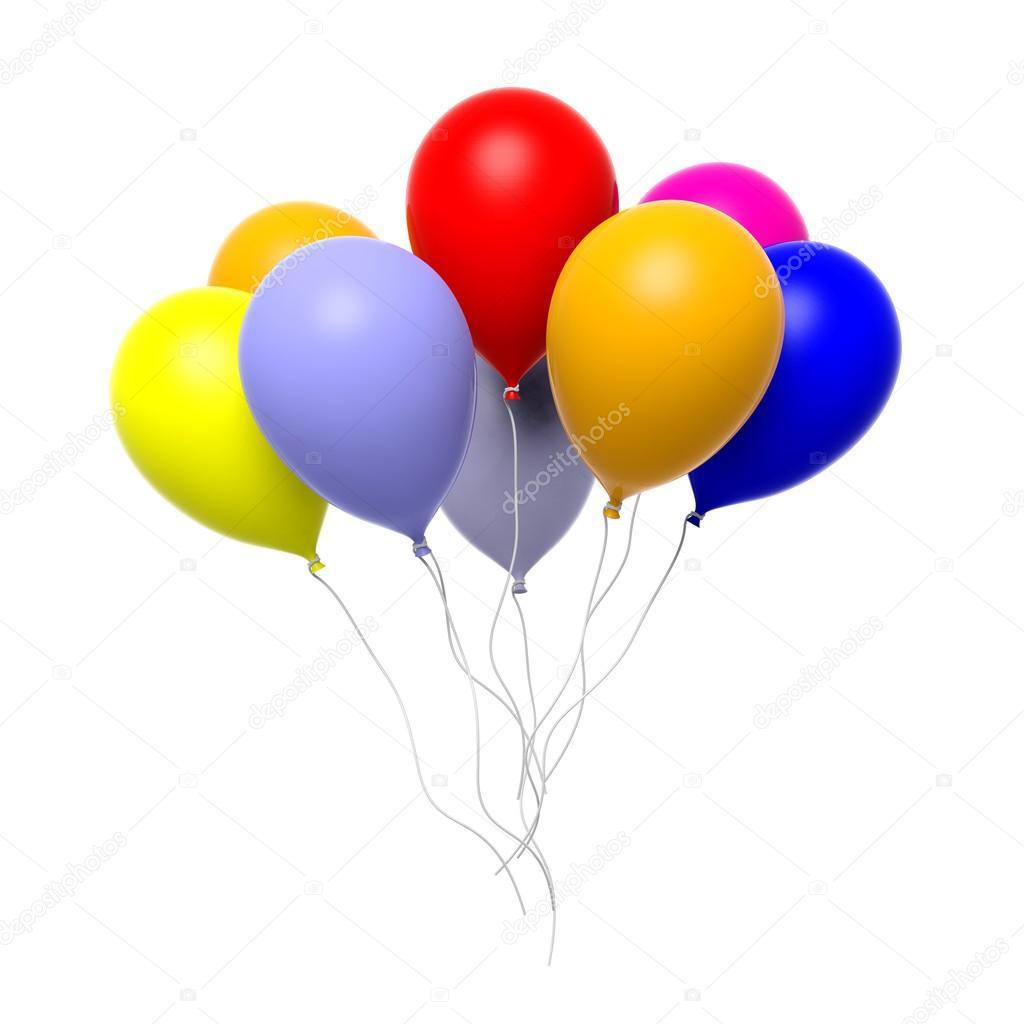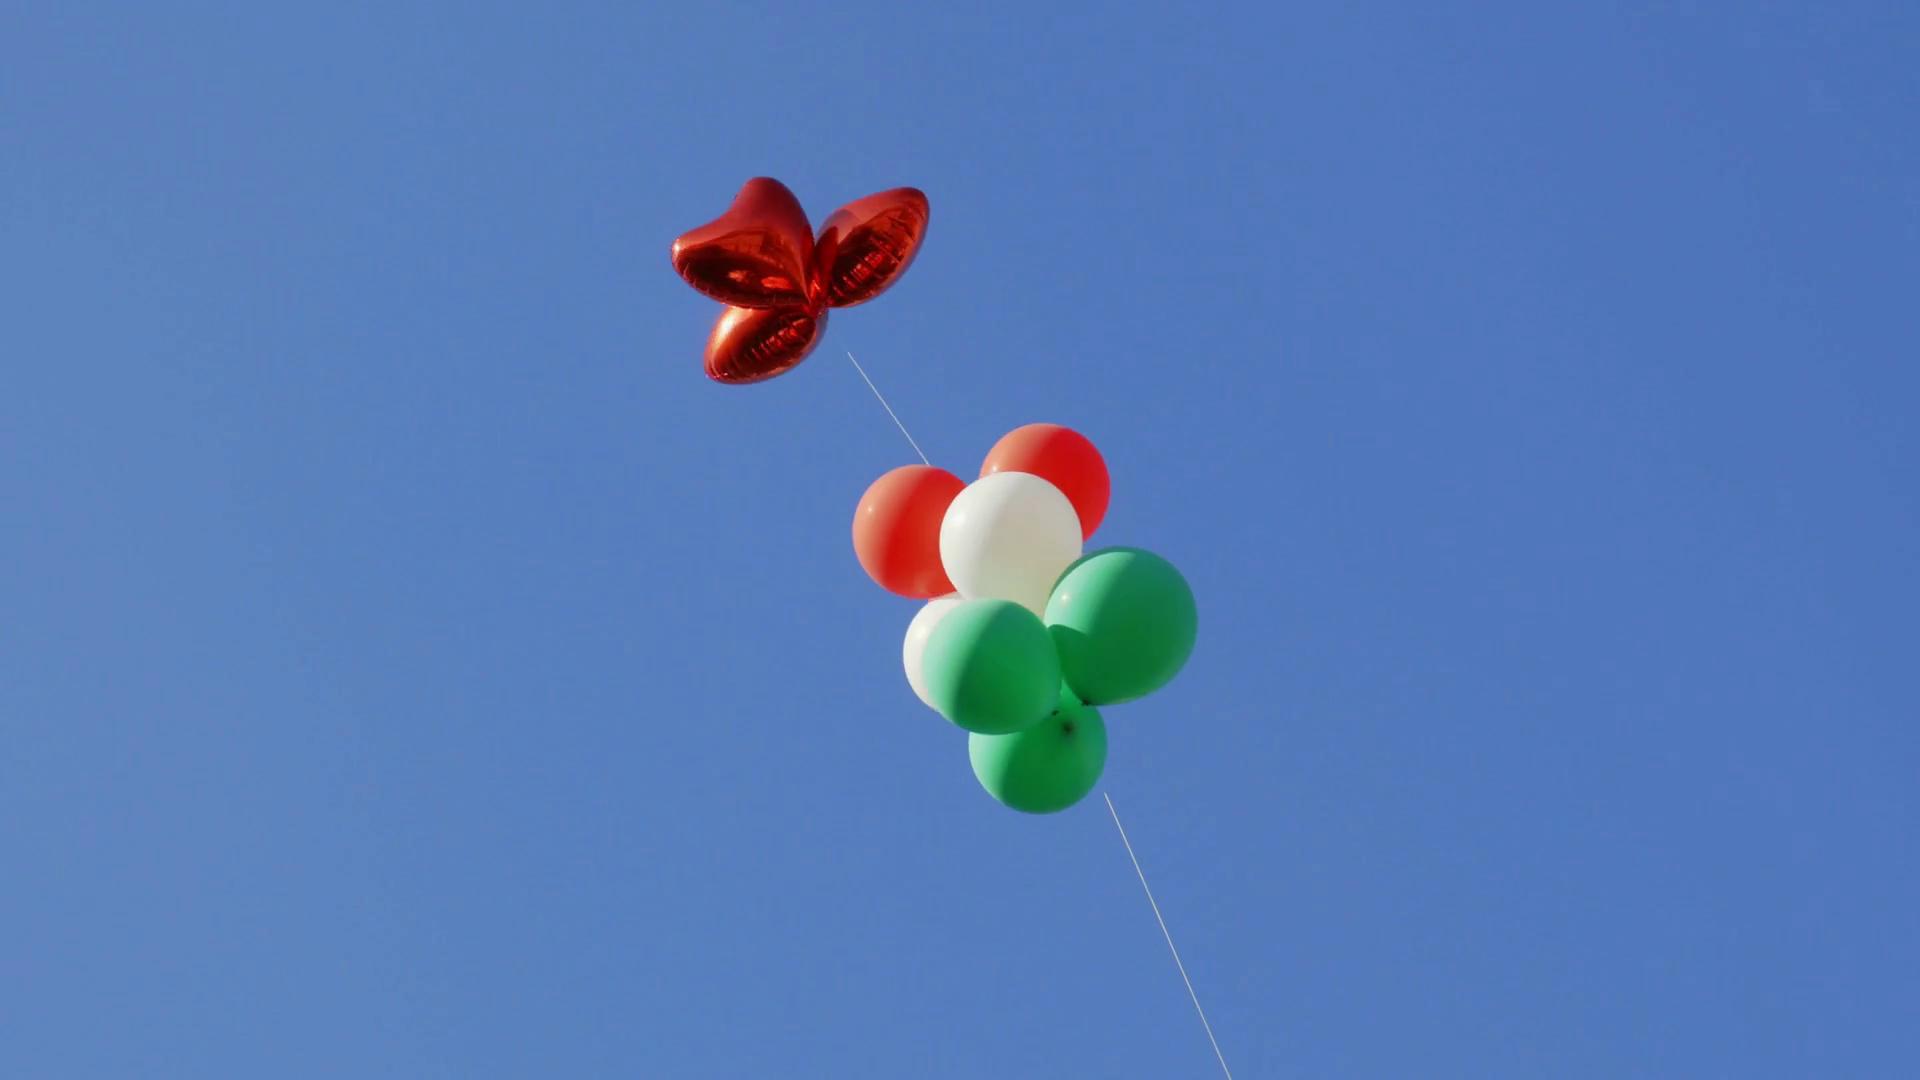The first image is the image on the left, the second image is the image on the right. For the images shown, is this caption "In at least one image there are eight balloon with strings on them." true? Answer yes or no. Yes. 